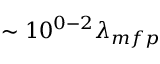<formula> <loc_0><loc_0><loc_500><loc_500>\sim 1 0 ^ { 0 - 2 } \lambda _ { m f p }</formula> 